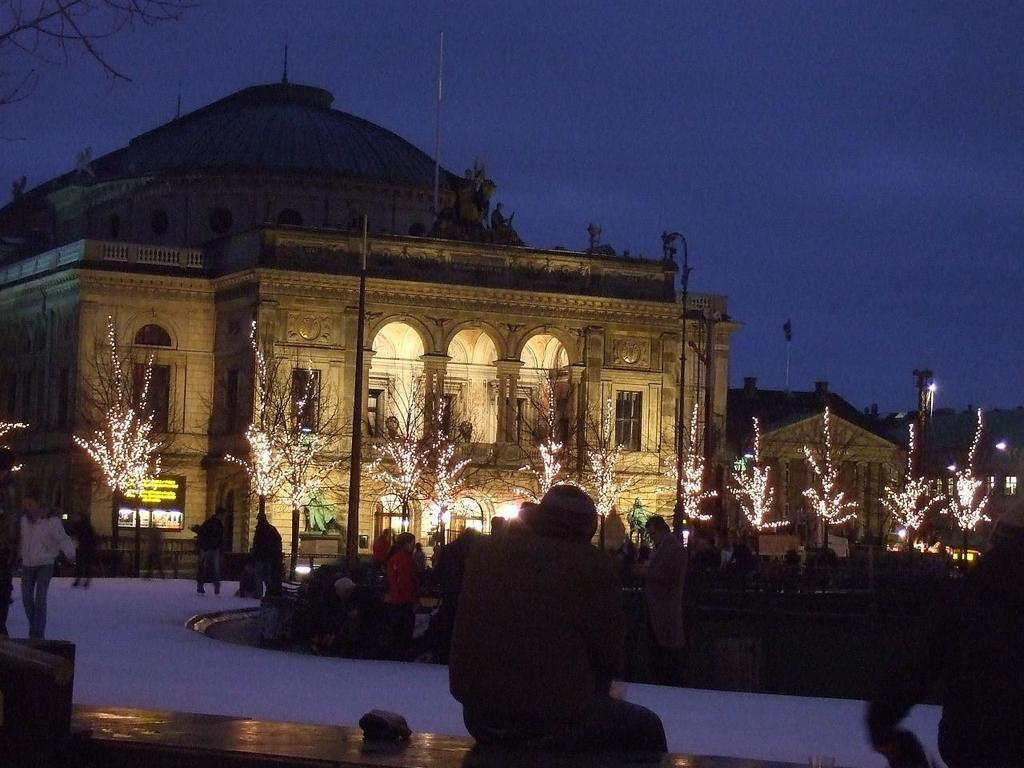What are the people in the image doing? The people in the image are walking on a path. What can be seen in the background of the image? There are buildings and trees in the background of the image. What is the condition of the trees in the image? The trees have lights on them. How is the sky in the image? The sky is clear in the image. How many rings are visible on the people's fingers in the image? There are no rings visible on the people's fingers in the image. What type of vacation are the people taking in the image? There is no indication of a vacation in the image; it simply shows people walking on a path. 